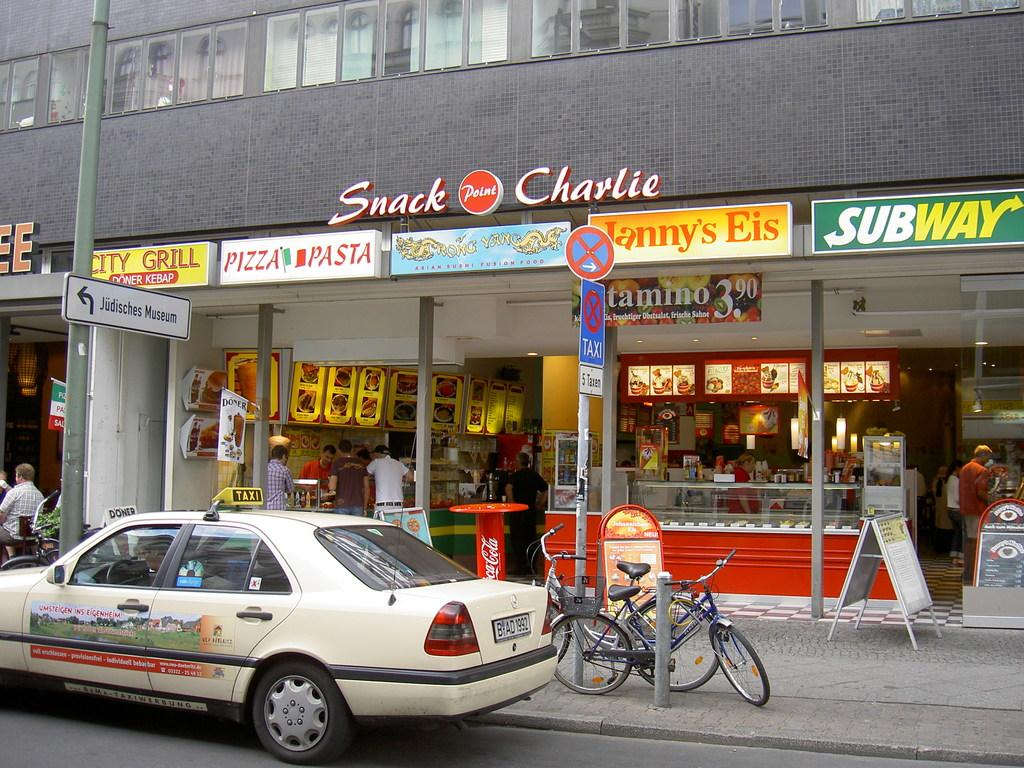Provide a one-sentence caption for the provided image. A car in front of Snack Charlie cafe. 